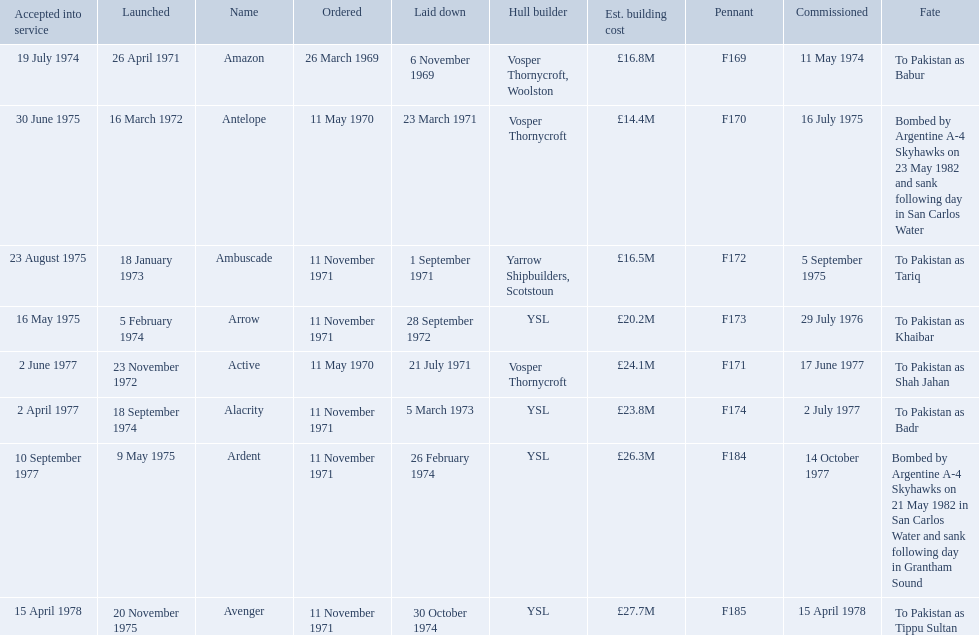What were the estimated building costs of the frigates? £16.8M, £14.4M, £16.5M, £20.2M, £24.1M, £23.8M, £26.3M, £27.7M. Which of these is the largest? £27.7M. What ship name does that correspond to? Avenger. 